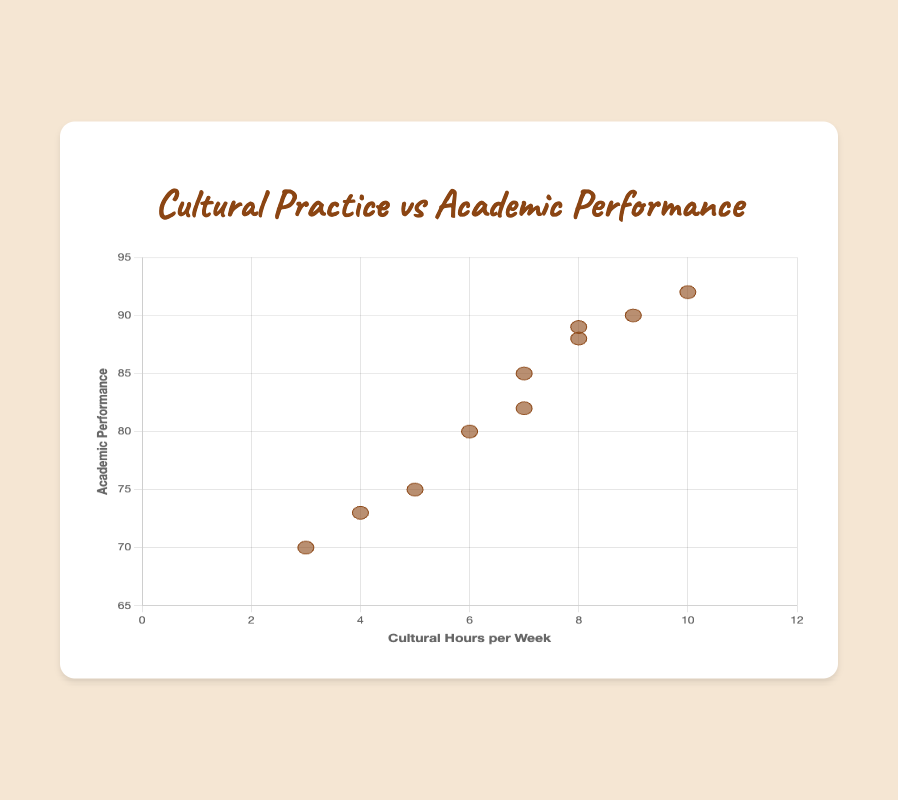What is the title of the scatter plot? The title of a plot is usually displayed at the top. In this case, the title is "Cultural Practice vs Academic Performance".
Answer: Cultural Practice vs Academic Performance How many students are included in the scatter plot? By counting the data points in the dataset, you see there are ten data points corresponding to ten students.
Answer: 10 Which student has the highest academic performance and how many cultural hours do they spend per week? By looking at the scatter plot, you can identify the highest point. Elijah Thundercloud has the highest academic performance of 92% and spends 10 cultural hours per week.
Answer: Elijah Thundercloud, 10 hours What is the range of academic performance scores depicted in the scatter plot? The plot shows academic performance on the y-axis ranging from the minimum value of 70% to the maximum value of 92%.
Answer: 70% to 92% Which student from the Hopi tribe is represented in the scatter plot, and what are his values for cultural hours per week and academic performance? Looking at the data points, Oliver Bearclaw from the Hopi tribe spends 9 hours per week on cultural practices and has an academic performance of 90%.
Answer: Oliver Bearclaw, 9 hours, 90% Is there any student with an equal amount of cultural hours per week and academic performance score? Checking each data point, none of the students have equal values for cultural hours per week and academic performance.
Answer: No What is the average academic performance of students who spend more than 7 cultural hours per week? Students meeting the criteria are Liam Greywolf (88), Elijah Thundercloud (92), Oliver Bearclaw (90), Isabella Spiritwalker (89). Adding these scores and dividing by 4 gives (88 + 92 + 90 + 89) / 4 = 89.75.
Answer: 89.75 Which students spend exactly 7 hours per week on cultural practices and what is their average academic performance? The students are Mia Skywalker (85) and William Eagleheart (82). Their average performance is (85 + 82) / 2 = 83.5.
Answer: Mia Skywalker, William Eagleheart, 83.5 Do the students spending the least amount of cultural hours per week have higher or lower academic performance compared to those spending the most hours? Ava Stonelake spends the least (3 hours, 70%) and Elijah Thundercloud spends the most (10 hours, 92%). Comparing these, students spending less cultural hours seem to have lower academic performance.
Answer: Lower Is there a general trend observed between cultural hours per week and academic performance? By observing the scatter plot, a general trend can be seen that as cultural hours per week increase, academic performance tends to be higher, although it's not perfectly linear.
Answer: Positive trend 